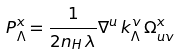<formula> <loc_0><loc_0><loc_500><loc_500>P ^ { x } _ { \Lambda } = \frac { 1 } { 2 n _ { H } \, \lambda } \nabla ^ { u } \, k _ { \Lambda } ^ { v } \, \Omega ^ { x } _ { u v }</formula> 